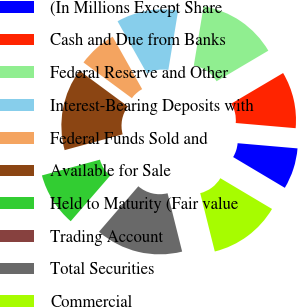<chart> <loc_0><loc_0><loc_500><loc_500><pie_chart><fcel>(In Millions Except Share<fcel>Cash and Due from Banks<fcel>Federal Reserve and Other<fcel>Interest-Bearing Deposits with<fcel>Federal Funds Sold and<fcel>Available for Sale<fcel>Held to Maturity (Fair value<fcel>Trading Account<fcel>Total Securities<fcel>Commercial<nl><fcel>7.17%<fcel>9.87%<fcel>13.9%<fcel>10.76%<fcel>6.73%<fcel>14.35%<fcel>9.42%<fcel>0.0%<fcel>15.25%<fcel>12.56%<nl></chart> 